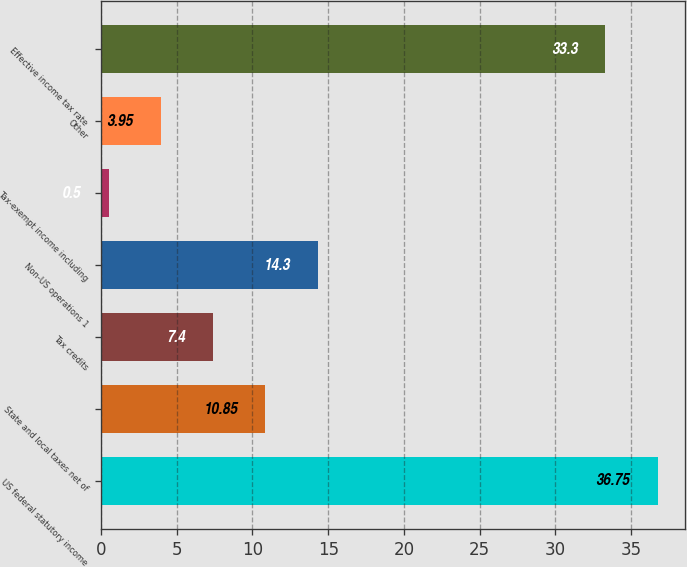Convert chart to OTSL. <chart><loc_0><loc_0><loc_500><loc_500><bar_chart><fcel>US federal statutory income<fcel>State and local taxes net of<fcel>Tax credits<fcel>Non-US operations 1<fcel>Tax-exempt income including<fcel>Other<fcel>Effective income tax rate<nl><fcel>36.75<fcel>10.85<fcel>7.4<fcel>14.3<fcel>0.5<fcel>3.95<fcel>33.3<nl></chart> 